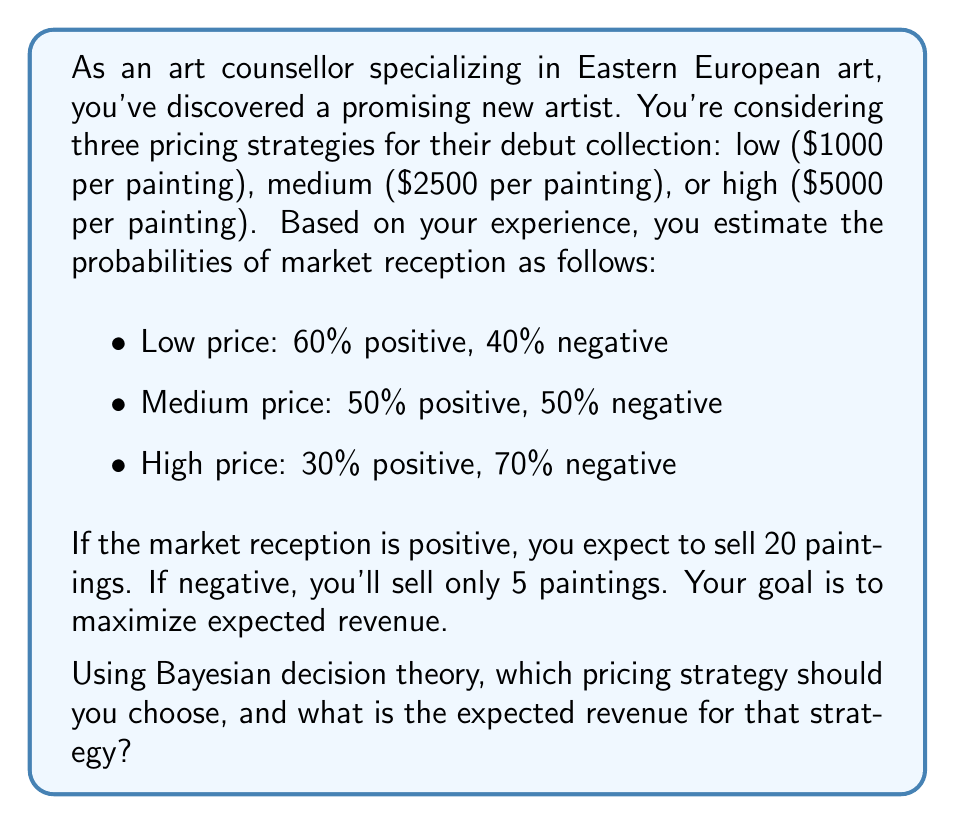Could you help me with this problem? Let's approach this problem using Bayesian decision theory:

1) First, let's define our decision space $D$ and our state space $S$:
   $D$ = {Low, Medium, High}
   $S$ = {Positive, Negative}

2) Now, let's create a payoff matrix for each combination of decision and state:

   Low price:
   Positive: $20 * 1000 = $20,000
   Negative: $5 * 1000 = $5,000

   Medium price:
   Positive: $20 * 2500 = $50,000
   Negative: $5 * 2500 = $12,500

   High price:
   Positive: $20 * 5000 = $100,000
   Negative: $5 * 5000 = $25,000

3) Next, we'll calculate the expected value for each decision using the formula:

   $E(d) = \sum_{s \in S} P(s|d) * U(d,s)$

   Where $P(s|d)$ is the probability of state $s$ given decision $d$, and $U(d,s)$ is the utility (in this case, revenue) for decision $d$ and state $s$.

4) Calculating expected values:

   Low price:
   $E(Low) = 0.6 * 20,000 + 0.4 * 5,000 = 12,000 + 2,000 = $14,000

   Medium price:
   $E(Medium) = 0.5 * 50,000 + 0.5 * 12,500 = 25,000 + 6,250 = $31,250

   High price:
   $E(High) = 0.3 * 100,000 + 0.7 * 25,000 = 30,000 + 17,500 = $47,500

5) The optimal decision is the one with the highest expected value, which in this case is the High price strategy with an expected revenue of $47,500.
Answer: The optimal pricing strategy is the High price ($5000 per painting), with an expected revenue of $47,500. 